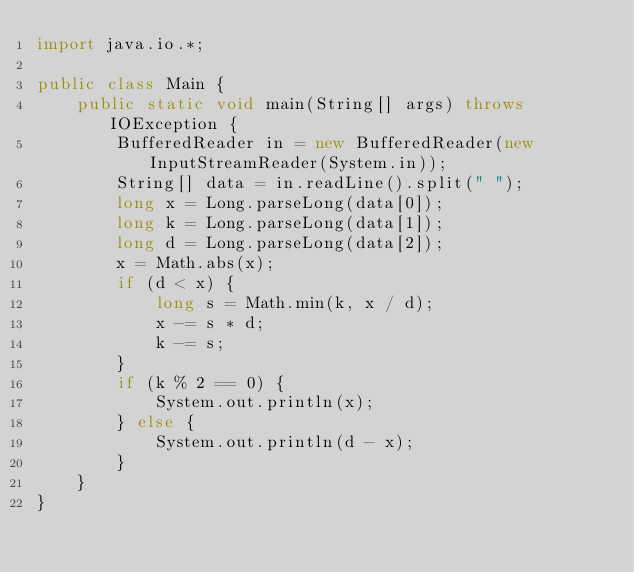Convert code to text. <code><loc_0><loc_0><loc_500><loc_500><_Java_>import java.io.*;

public class Main {
    public static void main(String[] args) throws IOException {
        BufferedReader in = new BufferedReader(new InputStreamReader(System.in));
        String[] data = in.readLine().split(" ");
        long x = Long.parseLong(data[0]);
        long k = Long.parseLong(data[1]);
        long d = Long.parseLong(data[2]);
        x = Math.abs(x);
        if (d < x) {
            long s = Math.min(k, x / d);
            x -= s * d;
            k -= s;
        }
        if (k % 2 == 0) {
            System.out.println(x);
        } else {
            System.out.println(d - x);
        }
    }
}
</code> 